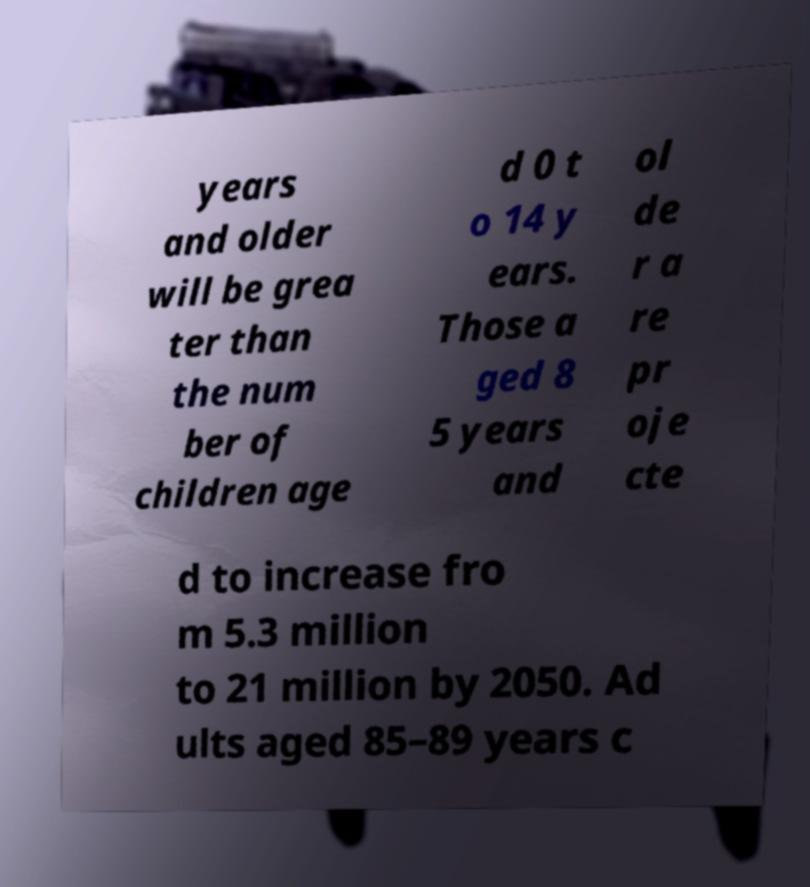There's text embedded in this image that I need extracted. Can you transcribe it verbatim? years and older will be grea ter than the num ber of children age d 0 t o 14 y ears. Those a ged 8 5 years and ol de r a re pr oje cte d to increase fro m 5.3 million to 21 million by 2050. Ad ults aged 85–89 years c 